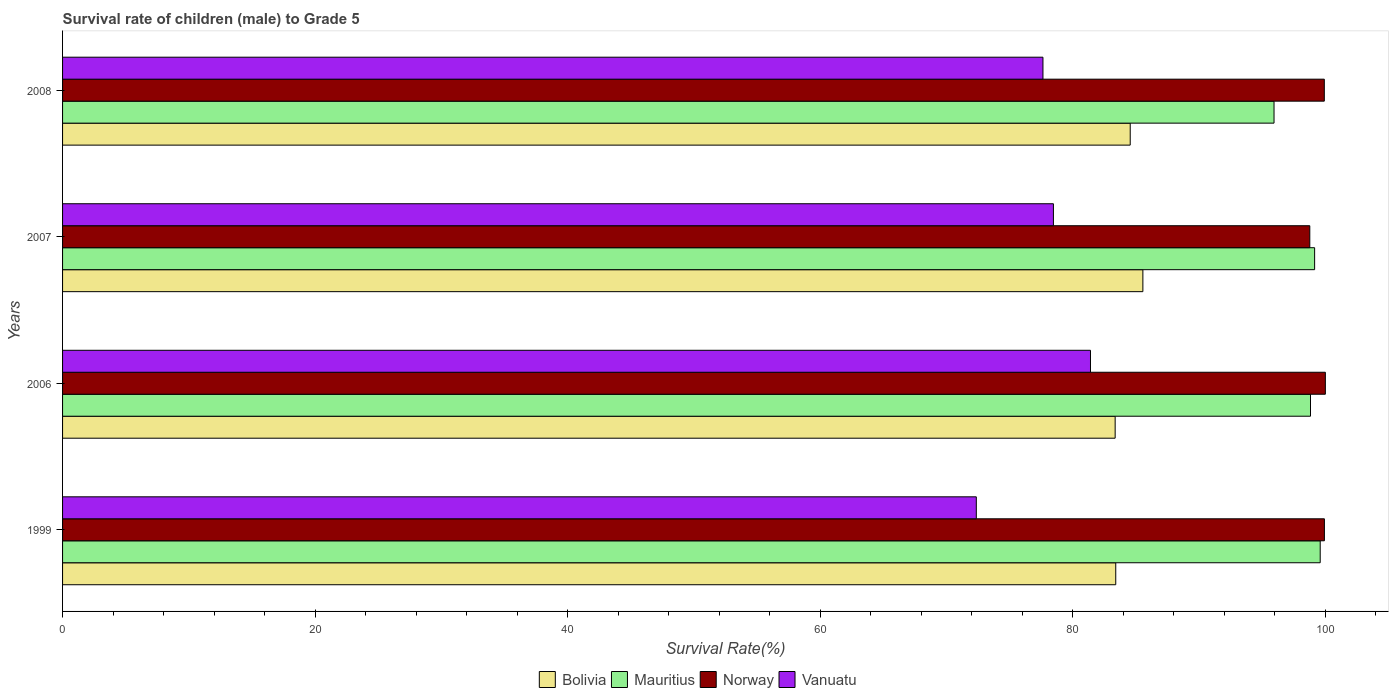Are the number of bars per tick equal to the number of legend labels?
Your response must be concise. Yes. How many bars are there on the 3rd tick from the top?
Provide a succinct answer. 4. How many bars are there on the 2nd tick from the bottom?
Your response must be concise. 4. In how many cases, is the number of bars for a given year not equal to the number of legend labels?
Provide a succinct answer. 0. What is the survival rate of male children to grade 5 in Norway in 2008?
Your response must be concise. 99.92. Across all years, what is the maximum survival rate of male children to grade 5 in Norway?
Your response must be concise. 100. Across all years, what is the minimum survival rate of male children to grade 5 in Vanuatu?
Your response must be concise. 72.36. What is the total survival rate of male children to grade 5 in Bolivia in the graph?
Your answer should be very brief. 336.85. What is the difference between the survival rate of male children to grade 5 in Norway in 1999 and that in 2007?
Keep it short and to the point. 1.16. What is the difference between the survival rate of male children to grade 5 in Mauritius in 2007 and the survival rate of male children to grade 5 in Bolivia in 1999?
Offer a terse response. 15.75. What is the average survival rate of male children to grade 5 in Norway per year?
Offer a terse response. 99.65. In the year 2008, what is the difference between the survival rate of male children to grade 5 in Mauritius and survival rate of male children to grade 5 in Bolivia?
Offer a very short reply. 11.39. What is the ratio of the survival rate of male children to grade 5 in Vanuatu in 1999 to that in 2007?
Your answer should be very brief. 0.92. Is the difference between the survival rate of male children to grade 5 in Mauritius in 2007 and 2008 greater than the difference between the survival rate of male children to grade 5 in Bolivia in 2007 and 2008?
Offer a terse response. Yes. What is the difference between the highest and the second highest survival rate of male children to grade 5 in Vanuatu?
Ensure brevity in your answer.  2.93. What is the difference between the highest and the lowest survival rate of male children to grade 5 in Norway?
Your response must be concise. 1.23. Is the sum of the survival rate of male children to grade 5 in Bolivia in 2006 and 2007 greater than the maximum survival rate of male children to grade 5 in Mauritius across all years?
Offer a very short reply. Yes. What does the 3rd bar from the top in 1999 represents?
Your response must be concise. Mauritius. What does the 2nd bar from the bottom in 1999 represents?
Your answer should be very brief. Mauritius. Are all the bars in the graph horizontal?
Give a very brief answer. Yes. How many years are there in the graph?
Provide a succinct answer. 4. Are the values on the major ticks of X-axis written in scientific E-notation?
Give a very brief answer. No. Does the graph contain any zero values?
Your answer should be very brief. No. Where does the legend appear in the graph?
Provide a short and direct response. Bottom center. How are the legend labels stacked?
Your answer should be compact. Horizontal. What is the title of the graph?
Your answer should be very brief. Survival rate of children (male) to Grade 5. Does "Austria" appear as one of the legend labels in the graph?
Keep it short and to the point. No. What is the label or title of the X-axis?
Offer a terse response. Survival Rate(%). What is the label or title of the Y-axis?
Keep it short and to the point. Years. What is the Survival Rate(%) of Bolivia in 1999?
Ensure brevity in your answer.  83.4. What is the Survival Rate(%) in Mauritius in 1999?
Your answer should be compact. 99.59. What is the Survival Rate(%) in Norway in 1999?
Offer a terse response. 99.92. What is the Survival Rate(%) in Vanuatu in 1999?
Keep it short and to the point. 72.36. What is the Survival Rate(%) in Bolivia in 2006?
Your answer should be very brief. 83.35. What is the Survival Rate(%) of Mauritius in 2006?
Offer a terse response. 98.82. What is the Survival Rate(%) of Norway in 2006?
Offer a very short reply. 100. What is the Survival Rate(%) in Vanuatu in 2006?
Make the answer very short. 81.4. What is the Survival Rate(%) of Bolivia in 2007?
Your answer should be very brief. 85.55. What is the Survival Rate(%) in Mauritius in 2007?
Give a very brief answer. 99.15. What is the Survival Rate(%) of Norway in 2007?
Offer a terse response. 98.77. What is the Survival Rate(%) of Vanuatu in 2007?
Offer a very short reply. 78.47. What is the Survival Rate(%) of Bolivia in 2008?
Your answer should be very brief. 84.55. What is the Survival Rate(%) in Mauritius in 2008?
Provide a short and direct response. 95.94. What is the Survival Rate(%) in Norway in 2008?
Your answer should be very brief. 99.92. What is the Survival Rate(%) of Vanuatu in 2008?
Your response must be concise. 77.64. Across all years, what is the maximum Survival Rate(%) of Bolivia?
Ensure brevity in your answer.  85.55. Across all years, what is the maximum Survival Rate(%) of Mauritius?
Keep it short and to the point. 99.59. Across all years, what is the maximum Survival Rate(%) in Norway?
Ensure brevity in your answer.  100. Across all years, what is the maximum Survival Rate(%) in Vanuatu?
Offer a terse response. 81.4. Across all years, what is the minimum Survival Rate(%) of Bolivia?
Your answer should be very brief. 83.35. Across all years, what is the minimum Survival Rate(%) in Mauritius?
Provide a succinct answer. 95.94. Across all years, what is the minimum Survival Rate(%) of Norway?
Your response must be concise. 98.77. Across all years, what is the minimum Survival Rate(%) in Vanuatu?
Give a very brief answer. 72.36. What is the total Survival Rate(%) in Bolivia in the graph?
Provide a succinct answer. 336.85. What is the total Survival Rate(%) in Mauritius in the graph?
Give a very brief answer. 393.5. What is the total Survival Rate(%) of Norway in the graph?
Make the answer very short. 398.61. What is the total Survival Rate(%) of Vanuatu in the graph?
Your response must be concise. 309.86. What is the difference between the Survival Rate(%) of Bolivia in 1999 and that in 2006?
Offer a terse response. 0.05. What is the difference between the Survival Rate(%) in Mauritius in 1999 and that in 2006?
Your response must be concise. 0.77. What is the difference between the Survival Rate(%) of Norway in 1999 and that in 2006?
Give a very brief answer. -0.08. What is the difference between the Survival Rate(%) in Vanuatu in 1999 and that in 2006?
Provide a short and direct response. -9.04. What is the difference between the Survival Rate(%) in Bolivia in 1999 and that in 2007?
Ensure brevity in your answer.  -2.15. What is the difference between the Survival Rate(%) in Mauritius in 1999 and that in 2007?
Offer a very short reply. 0.44. What is the difference between the Survival Rate(%) in Norway in 1999 and that in 2007?
Offer a very short reply. 1.16. What is the difference between the Survival Rate(%) in Vanuatu in 1999 and that in 2007?
Keep it short and to the point. -6.11. What is the difference between the Survival Rate(%) of Bolivia in 1999 and that in 2008?
Offer a terse response. -1.15. What is the difference between the Survival Rate(%) of Mauritius in 1999 and that in 2008?
Ensure brevity in your answer.  3.66. What is the difference between the Survival Rate(%) of Norway in 1999 and that in 2008?
Make the answer very short. 0.01. What is the difference between the Survival Rate(%) of Vanuatu in 1999 and that in 2008?
Offer a very short reply. -5.28. What is the difference between the Survival Rate(%) in Bolivia in 2006 and that in 2007?
Your answer should be compact. -2.2. What is the difference between the Survival Rate(%) in Mauritius in 2006 and that in 2007?
Give a very brief answer. -0.33. What is the difference between the Survival Rate(%) in Norway in 2006 and that in 2007?
Ensure brevity in your answer.  1.23. What is the difference between the Survival Rate(%) of Vanuatu in 2006 and that in 2007?
Ensure brevity in your answer.  2.93. What is the difference between the Survival Rate(%) in Bolivia in 2006 and that in 2008?
Give a very brief answer. -1.19. What is the difference between the Survival Rate(%) in Mauritius in 2006 and that in 2008?
Make the answer very short. 2.89. What is the difference between the Survival Rate(%) in Norway in 2006 and that in 2008?
Your response must be concise. 0.08. What is the difference between the Survival Rate(%) of Vanuatu in 2006 and that in 2008?
Provide a short and direct response. 3.76. What is the difference between the Survival Rate(%) in Mauritius in 2007 and that in 2008?
Provide a short and direct response. 3.22. What is the difference between the Survival Rate(%) of Norway in 2007 and that in 2008?
Provide a short and direct response. -1.15. What is the difference between the Survival Rate(%) in Vanuatu in 2007 and that in 2008?
Make the answer very short. 0.83. What is the difference between the Survival Rate(%) of Bolivia in 1999 and the Survival Rate(%) of Mauritius in 2006?
Offer a terse response. -15.42. What is the difference between the Survival Rate(%) of Bolivia in 1999 and the Survival Rate(%) of Norway in 2006?
Offer a terse response. -16.6. What is the difference between the Survival Rate(%) of Bolivia in 1999 and the Survival Rate(%) of Vanuatu in 2006?
Provide a succinct answer. 2. What is the difference between the Survival Rate(%) of Mauritius in 1999 and the Survival Rate(%) of Norway in 2006?
Your response must be concise. -0.41. What is the difference between the Survival Rate(%) of Mauritius in 1999 and the Survival Rate(%) of Vanuatu in 2006?
Your response must be concise. 18.19. What is the difference between the Survival Rate(%) of Norway in 1999 and the Survival Rate(%) of Vanuatu in 2006?
Provide a succinct answer. 18.52. What is the difference between the Survival Rate(%) in Bolivia in 1999 and the Survival Rate(%) in Mauritius in 2007?
Offer a terse response. -15.75. What is the difference between the Survival Rate(%) in Bolivia in 1999 and the Survival Rate(%) in Norway in 2007?
Provide a succinct answer. -15.37. What is the difference between the Survival Rate(%) of Bolivia in 1999 and the Survival Rate(%) of Vanuatu in 2007?
Provide a short and direct response. 4.94. What is the difference between the Survival Rate(%) of Mauritius in 1999 and the Survival Rate(%) of Norway in 2007?
Your answer should be compact. 0.82. What is the difference between the Survival Rate(%) in Mauritius in 1999 and the Survival Rate(%) in Vanuatu in 2007?
Provide a succinct answer. 21.13. What is the difference between the Survival Rate(%) of Norway in 1999 and the Survival Rate(%) of Vanuatu in 2007?
Make the answer very short. 21.46. What is the difference between the Survival Rate(%) in Bolivia in 1999 and the Survival Rate(%) in Mauritius in 2008?
Offer a very short reply. -12.53. What is the difference between the Survival Rate(%) of Bolivia in 1999 and the Survival Rate(%) of Norway in 2008?
Give a very brief answer. -16.52. What is the difference between the Survival Rate(%) of Bolivia in 1999 and the Survival Rate(%) of Vanuatu in 2008?
Your answer should be very brief. 5.76. What is the difference between the Survival Rate(%) of Mauritius in 1999 and the Survival Rate(%) of Norway in 2008?
Your answer should be compact. -0.33. What is the difference between the Survival Rate(%) in Mauritius in 1999 and the Survival Rate(%) in Vanuatu in 2008?
Offer a terse response. 21.96. What is the difference between the Survival Rate(%) in Norway in 1999 and the Survival Rate(%) in Vanuatu in 2008?
Keep it short and to the point. 22.29. What is the difference between the Survival Rate(%) in Bolivia in 2006 and the Survival Rate(%) in Mauritius in 2007?
Keep it short and to the point. -15.8. What is the difference between the Survival Rate(%) of Bolivia in 2006 and the Survival Rate(%) of Norway in 2007?
Your response must be concise. -15.41. What is the difference between the Survival Rate(%) of Bolivia in 2006 and the Survival Rate(%) of Vanuatu in 2007?
Make the answer very short. 4.89. What is the difference between the Survival Rate(%) in Mauritius in 2006 and the Survival Rate(%) in Norway in 2007?
Offer a very short reply. 0.06. What is the difference between the Survival Rate(%) in Mauritius in 2006 and the Survival Rate(%) in Vanuatu in 2007?
Your answer should be very brief. 20.36. What is the difference between the Survival Rate(%) in Norway in 2006 and the Survival Rate(%) in Vanuatu in 2007?
Ensure brevity in your answer.  21.53. What is the difference between the Survival Rate(%) of Bolivia in 2006 and the Survival Rate(%) of Mauritius in 2008?
Keep it short and to the point. -12.58. What is the difference between the Survival Rate(%) of Bolivia in 2006 and the Survival Rate(%) of Norway in 2008?
Your response must be concise. -16.56. What is the difference between the Survival Rate(%) in Bolivia in 2006 and the Survival Rate(%) in Vanuatu in 2008?
Your answer should be very brief. 5.72. What is the difference between the Survival Rate(%) of Mauritius in 2006 and the Survival Rate(%) of Norway in 2008?
Ensure brevity in your answer.  -1.09. What is the difference between the Survival Rate(%) of Mauritius in 2006 and the Survival Rate(%) of Vanuatu in 2008?
Give a very brief answer. 21.19. What is the difference between the Survival Rate(%) in Norway in 2006 and the Survival Rate(%) in Vanuatu in 2008?
Your response must be concise. 22.36. What is the difference between the Survival Rate(%) in Bolivia in 2007 and the Survival Rate(%) in Mauritius in 2008?
Ensure brevity in your answer.  -10.39. What is the difference between the Survival Rate(%) of Bolivia in 2007 and the Survival Rate(%) of Norway in 2008?
Your answer should be very brief. -14.37. What is the difference between the Survival Rate(%) in Bolivia in 2007 and the Survival Rate(%) in Vanuatu in 2008?
Your response must be concise. 7.91. What is the difference between the Survival Rate(%) in Mauritius in 2007 and the Survival Rate(%) in Norway in 2008?
Your response must be concise. -0.77. What is the difference between the Survival Rate(%) in Mauritius in 2007 and the Survival Rate(%) in Vanuatu in 2008?
Give a very brief answer. 21.51. What is the difference between the Survival Rate(%) in Norway in 2007 and the Survival Rate(%) in Vanuatu in 2008?
Make the answer very short. 21.13. What is the average Survival Rate(%) of Bolivia per year?
Your response must be concise. 84.21. What is the average Survival Rate(%) of Mauritius per year?
Provide a succinct answer. 98.38. What is the average Survival Rate(%) of Norway per year?
Offer a terse response. 99.65. What is the average Survival Rate(%) in Vanuatu per year?
Ensure brevity in your answer.  77.47. In the year 1999, what is the difference between the Survival Rate(%) in Bolivia and Survival Rate(%) in Mauritius?
Keep it short and to the point. -16.19. In the year 1999, what is the difference between the Survival Rate(%) of Bolivia and Survival Rate(%) of Norway?
Offer a terse response. -16.52. In the year 1999, what is the difference between the Survival Rate(%) in Bolivia and Survival Rate(%) in Vanuatu?
Give a very brief answer. 11.04. In the year 1999, what is the difference between the Survival Rate(%) in Mauritius and Survival Rate(%) in Norway?
Provide a succinct answer. -0.33. In the year 1999, what is the difference between the Survival Rate(%) in Mauritius and Survival Rate(%) in Vanuatu?
Provide a succinct answer. 27.23. In the year 1999, what is the difference between the Survival Rate(%) in Norway and Survival Rate(%) in Vanuatu?
Provide a short and direct response. 27.57. In the year 2006, what is the difference between the Survival Rate(%) of Bolivia and Survival Rate(%) of Mauritius?
Offer a very short reply. -15.47. In the year 2006, what is the difference between the Survival Rate(%) of Bolivia and Survival Rate(%) of Norway?
Offer a terse response. -16.65. In the year 2006, what is the difference between the Survival Rate(%) in Bolivia and Survival Rate(%) in Vanuatu?
Keep it short and to the point. 1.95. In the year 2006, what is the difference between the Survival Rate(%) in Mauritius and Survival Rate(%) in Norway?
Your answer should be very brief. -1.18. In the year 2006, what is the difference between the Survival Rate(%) in Mauritius and Survival Rate(%) in Vanuatu?
Keep it short and to the point. 17.42. In the year 2006, what is the difference between the Survival Rate(%) of Norway and Survival Rate(%) of Vanuatu?
Keep it short and to the point. 18.6. In the year 2007, what is the difference between the Survival Rate(%) in Bolivia and Survival Rate(%) in Mauritius?
Provide a short and direct response. -13.6. In the year 2007, what is the difference between the Survival Rate(%) in Bolivia and Survival Rate(%) in Norway?
Offer a very short reply. -13.22. In the year 2007, what is the difference between the Survival Rate(%) in Bolivia and Survival Rate(%) in Vanuatu?
Provide a short and direct response. 7.08. In the year 2007, what is the difference between the Survival Rate(%) in Mauritius and Survival Rate(%) in Norway?
Your answer should be compact. 0.38. In the year 2007, what is the difference between the Survival Rate(%) of Mauritius and Survival Rate(%) of Vanuatu?
Offer a terse response. 20.68. In the year 2007, what is the difference between the Survival Rate(%) of Norway and Survival Rate(%) of Vanuatu?
Provide a succinct answer. 20.3. In the year 2008, what is the difference between the Survival Rate(%) of Bolivia and Survival Rate(%) of Mauritius?
Provide a short and direct response. -11.39. In the year 2008, what is the difference between the Survival Rate(%) of Bolivia and Survival Rate(%) of Norway?
Keep it short and to the point. -15.37. In the year 2008, what is the difference between the Survival Rate(%) in Bolivia and Survival Rate(%) in Vanuatu?
Keep it short and to the point. 6.91. In the year 2008, what is the difference between the Survival Rate(%) in Mauritius and Survival Rate(%) in Norway?
Your answer should be compact. -3.98. In the year 2008, what is the difference between the Survival Rate(%) of Mauritius and Survival Rate(%) of Vanuatu?
Ensure brevity in your answer.  18.3. In the year 2008, what is the difference between the Survival Rate(%) of Norway and Survival Rate(%) of Vanuatu?
Ensure brevity in your answer.  22.28. What is the ratio of the Survival Rate(%) of Bolivia in 1999 to that in 2006?
Provide a succinct answer. 1. What is the ratio of the Survival Rate(%) of Norway in 1999 to that in 2006?
Offer a terse response. 1. What is the ratio of the Survival Rate(%) in Vanuatu in 1999 to that in 2006?
Offer a terse response. 0.89. What is the ratio of the Survival Rate(%) in Bolivia in 1999 to that in 2007?
Keep it short and to the point. 0.97. What is the ratio of the Survival Rate(%) in Norway in 1999 to that in 2007?
Your answer should be very brief. 1.01. What is the ratio of the Survival Rate(%) in Vanuatu in 1999 to that in 2007?
Your response must be concise. 0.92. What is the ratio of the Survival Rate(%) of Bolivia in 1999 to that in 2008?
Give a very brief answer. 0.99. What is the ratio of the Survival Rate(%) of Mauritius in 1999 to that in 2008?
Your answer should be compact. 1.04. What is the ratio of the Survival Rate(%) of Vanuatu in 1999 to that in 2008?
Keep it short and to the point. 0.93. What is the ratio of the Survival Rate(%) of Bolivia in 2006 to that in 2007?
Your response must be concise. 0.97. What is the ratio of the Survival Rate(%) of Mauritius in 2006 to that in 2007?
Offer a very short reply. 1. What is the ratio of the Survival Rate(%) of Norway in 2006 to that in 2007?
Give a very brief answer. 1.01. What is the ratio of the Survival Rate(%) in Vanuatu in 2006 to that in 2007?
Give a very brief answer. 1.04. What is the ratio of the Survival Rate(%) of Bolivia in 2006 to that in 2008?
Offer a terse response. 0.99. What is the ratio of the Survival Rate(%) in Mauritius in 2006 to that in 2008?
Your answer should be compact. 1.03. What is the ratio of the Survival Rate(%) of Vanuatu in 2006 to that in 2008?
Your answer should be very brief. 1.05. What is the ratio of the Survival Rate(%) in Bolivia in 2007 to that in 2008?
Provide a succinct answer. 1.01. What is the ratio of the Survival Rate(%) of Mauritius in 2007 to that in 2008?
Provide a short and direct response. 1.03. What is the ratio of the Survival Rate(%) of Norway in 2007 to that in 2008?
Your response must be concise. 0.99. What is the ratio of the Survival Rate(%) in Vanuatu in 2007 to that in 2008?
Your response must be concise. 1.01. What is the difference between the highest and the second highest Survival Rate(%) of Mauritius?
Provide a succinct answer. 0.44. What is the difference between the highest and the second highest Survival Rate(%) of Norway?
Ensure brevity in your answer.  0.08. What is the difference between the highest and the second highest Survival Rate(%) in Vanuatu?
Your response must be concise. 2.93. What is the difference between the highest and the lowest Survival Rate(%) of Bolivia?
Keep it short and to the point. 2.2. What is the difference between the highest and the lowest Survival Rate(%) of Mauritius?
Your answer should be very brief. 3.66. What is the difference between the highest and the lowest Survival Rate(%) in Norway?
Keep it short and to the point. 1.23. What is the difference between the highest and the lowest Survival Rate(%) of Vanuatu?
Make the answer very short. 9.04. 